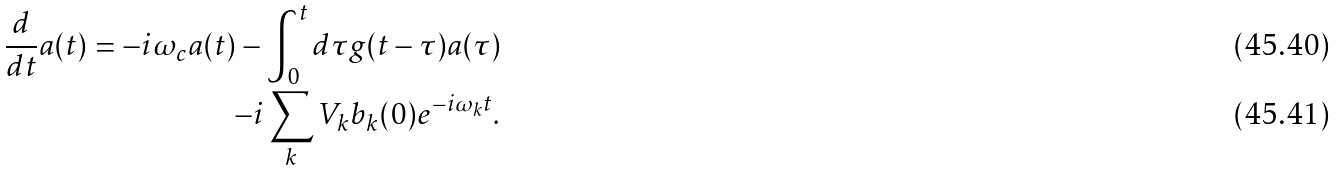<formula> <loc_0><loc_0><loc_500><loc_500>\frac { d } { d t } a ( t ) = - i \omega _ { c } a ( t ) - \int _ { 0 } ^ { t } d \tau g ( t - \tau ) a ( \tau ) \\ - i \sum _ { k } V _ { k } b _ { k } ( 0 ) e ^ { - i \omega _ { k } t } .</formula> 